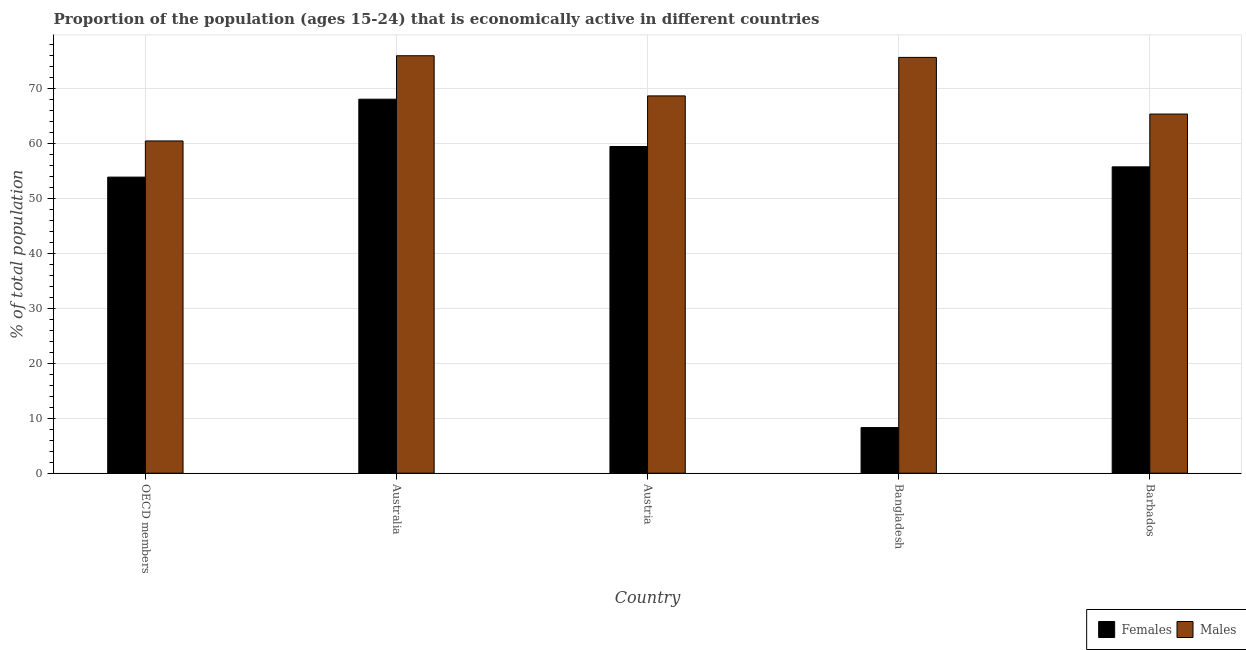How many bars are there on the 3rd tick from the left?
Ensure brevity in your answer.  2. How many bars are there on the 4th tick from the right?
Keep it short and to the point. 2. What is the label of the 5th group of bars from the left?
Make the answer very short. Barbados. In how many cases, is the number of bars for a given country not equal to the number of legend labels?
Give a very brief answer. 0. What is the percentage of economically active female population in Austria?
Keep it short and to the point. 59.4. Across all countries, what is the minimum percentage of economically active female population?
Ensure brevity in your answer.  8.3. In which country was the percentage of economically active female population minimum?
Ensure brevity in your answer.  Bangladesh. What is the total percentage of economically active female population in the graph?
Offer a terse response. 245.23. What is the difference between the percentage of economically active female population in Austria and that in OECD members?
Offer a very short reply. 5.57. What is the difference between the percentage of economically active male population in Bangladesh and the percentage of economically active female population in Barbados?
Your answer should be compact. 19.9. What is the average percentage of economically active male population per country?
Make the answer very short. 69.16. What is the difference between the percentage of economically active female population and percentage of economically active male population in Bangladesh?
Provide a short and direct response. -67.3. In how many countries, is the percentage of economically active female population greater than 42 %?
Ensure brevity in your answer.  4. What is the ratio of the percentage of economically active male population in Austria to that in Bangladesh?
Ensure brevity in your answer.  0.91. Is the percentage of economically active female population in Australia less than that in OECD members?
Provide a succinct answer. No. What is the difference between the highest and the second highest percentage of economically active male population?
Your answer should be very brief. 0.3. What is the difference between the highest and the lowest percentage of economically active female population?
Keep it short and to the point. 59.7. Is the sum of the percentage of economically active female population in Bangladesh and Barbados greater than the maximum percentage of economically active male population across all countries?
Make the answer very short. No. What does the 1st bar from the left in OECD members represents?
Your response must be concise. Females. What does the 1st bar from the right in Australia represents?
Keep it short and to the point. Males. How many bars are there?
Provide a short and direct response. 10. Are all the bars in the graph horizontal?
Give a very brief answer. No. Are the values on the major ticks of Y-axis written in scientific E-notation?
Your response must be concise. No. Does the graph contain any zero values?
Offer a very short reply. No. Does the graph contain grids?
Your answer should be very brief. Yes. How many legend labels are there?
Your answer should be very brief. 2. What is the title of the graph?
Your answer should be compact. Proportion of the population (ages 15-24) that is economically active in different countries. Does "Age 65(female)" appear as one of the legend labels in the graph?
Offer a very short reply. No. What is the label or title of the Y-axis?
Give a very brief answer. % of total population. What is the % of total population in Females in OECD members?
Ensure brevity in your answer.  53.83. What is the % of total population in Males in OECD members?
Ensure brevity in your answer.  60.41. What is the % of total population in Males in Australia?
Ensure brevity in your answer.  75.9. What is the % of total population in Females in Austria?
Offer a very short reply. 59.4. What is the % of total population in Males in Austria?
Your response must be concise. 68.6. What is the % of total population of Females in Bangladesh?
Your answer should be very brief. 8.3. What is the % of total population in Males in Bangladesh?
Keep it short and to the point. 75.6. What is the % of total population of Females in Barbados?
Keep it short and to the point. 55.7. What is the % of total population of Males in Barbados?
Provide a short and direct response. 65.3. Across all countries, what is the maximum % of total population in Males?
Your answer should be very brief. 75.9. Across all countries, what is the minimum % of total population of Females?
Keep it short and to the point. 8.3. Across all countries, what is the minimum % of total population in Males?
Your answer should be compact. 60.41. What is the total % of total population in Females in the graph?
Offer a terse response. 245.23. What is the total % of total population in Males in the graph?
Offer a very short reply. 345.81. What is the difference between the % of total population of Females in OECD members and that in Australia?
Your response must be concise. -14.17. What is the difference between the % of total population of Males in OECD members and that in Australia?
Offer a terse response. -15.49. What is the difference between the % of total population in Females in OECD members and that in Austria?
Offer a very short reply. -5.57. What is the difference between the % of total population of Males in OECD members and that in Austria?
Provide a succinct answer. -8.19. What is the difference between the % of total population of Females in OECD members and that in Bangladesh?
Give a very brief answer. 45.53. What is the difference between the % of total population of Males in OECD members and that in Bangladesh?
Provide a succinct answer. -15.19. What is the difference between the % of total population in Females in OECD members and that in Barbados?
Your response must be concise. -1.87. What is the difference between the % of total population in Males in OECD members and that in Barbados?
Your answer should be very brief. -4.89. What is the difference between the % of total population in Females in Australia and that in Austria?
Make the answer very short. 8.6. What is the difference between the % of total population of Females in Australia and that in Bangladesh?
Make the answer very short. 59.7. What is the difference between the % of total population of Males in Australia and that in Bangladesh?
Ensure brevity in your answer.  0.3. What is the difference between the % of total population in Females in Australia and that in Barbados?
Give a very brief answer. 12.3. What is the difference between the % of total population of Females in Austria and that in Bangladesh?
Your answer should be compact. 51.1. What is the difference between the % of total population of Males in Austria and that in Bangladesh?
Offer a terse response. -7. What is the difference between the % of total population of Females in Austria and that in Barbados?
Provide a succinct answer. 3.7. What is the difference between the % of total population in Females in Bangladesh and that in Barbados?
Your answer should be compact. -47.4. What is the difference between the % of total population of Females in OECD members and the % of total population of Males in Australia?
Your response must be concise. -22.07. What is the difference between the % of total population in Females in OECD members and the % of total population in Males in Austria?
Ensure brevity in your answer.  -14.77. What is the difference between the % of total population of Females in OECD members and the % of total population of Males in Bangladesh?
Offer a terse response. -21.77. What is the difference between the % of total population in Females in OECD members and the % of total population in Males in Barbados?
Offer a very short reply. -11.47. What is the difference between the % of total population of Females in Australia and the % of total population of Males in Bangladesh?
Provide a succinct answer. -7.6. What is the difference between the % of total population of Females in Austria and the % of total population of Males in Bangladesh?
Provide a succinct answer. -16.2. What is the difference between the % of total population of Females in Austria and the % of total population of Males in Barbados?
Your response must be concise. -5.9. What is the difference between the % of total population in Females in Bangladesh and the % of total population in Males in Barbados?
Provide a succinct answer. -57. What is the average % of total population of Females per country?
Ensure brevity in your answer.  49.05. What is the average % of total population of Males per country?
Provide a succinct answer. 69.16. What is the difference between the % of total population of Females and % of total population of Males in OECD members?
Offer a terse response. -6.57. What is the difference between the % of total population in Females and % of total population in Males in Austria?
Your answer should be very brief. -9.2. What is the difference between the % of total population of Females and % of total population of Males in Bangladesh?
Ensure brevity in your answer.  -67.3. What is the difference between the % of total population of Females and % of total population of Males in Barbados?
Provide a short and direct response. -9.6. What is the ratio of the % of total population in Females in OECD members to that in Australia?
Give a very brief answer. 0.79. What is the ratio of the % of total population in Males in OECD members to that in Australia?
Keep it short and to the point. 0.8. What is the ratio of the % of total population in Females in OECD members to that in Austria?
Your answer should be compact. 0.91. What is the ratio of the % of total population of Males in OECD members to that in Austria?
Provide a short and direct response. 0.88. What is the ratio of the % of total population in Females in OECD members to that in Bangladesh?
Provide a succinct answer. 6.49. What is the ratio of the % of total population in Males in OECD members to that in Bangladesh?
Give a very brief answer. 0.8. What is the ratio of the % of total population in Females in OECD members to that in Barbados?
Give a very brief answer. 0.97. What is the ratio of the % of total population of Males in OECD members to that in Barbados?
Offer a terse response. 0.93. What is the ratio of the % of total population in Females in Australia to that in Austria?
Give a very brief answer. 1.14. What is the ratio of the % of total population in Males in Australia to that in Austria?
Offer a very short reply. 1.11. What is the ratio of the % of total population in Females in Australia to that in Bangladesh?
Keep it short and to the point. 8.19. What is the ratio of the % of total population of Males in Australia to that in Bangladesh?
Offer a terse response. 1. What is the ratio of the % of total population in Females in Australia to that in Barbados?
Give a very brief answer. 1.22. What is the ratio of the % of total population in Males in Australia to that in Barbados?
Provide a succinct answer. 1.16. What is the ratio of the % of total population in Females in Austria to that in Bangladesh?
Keep it short and to the point. 7.16. What is the ratio of the % of total population in Males in Austria to that in Bangladesh?
Keep it short and to the point. 0.91. What is the ratio of the % of total population of Females in Austria to that in Barbados?
Ensure brevity in your answer.  1.07. What is the ratio of the % of total population of Males in Austria to that in Barbados?
Provide a succinct answer. 1.05. What is the ratio of the % of total population in Females in Bangladesh to that in Barbados?
Ensure brevity in your answer.  0.15. What is the ratio of the % of total population in Males in Bangladesh to that in Barbados?
Provide a succinct answer. 1.16. What is the difference between the highest and the second highest % of total population of Females?
Ensure brevity in your answer.  8.6. What is the difference between the highest and the second highest % of total population in Males?
Your response must be concise. 0.3. What is the difference between the highest and the lowest % of total population of Females?
Your response must be concise. 59.7. What is the difference between the highest and the lowest % of total population in Males?
Provide a succinct answer. 15.49. 